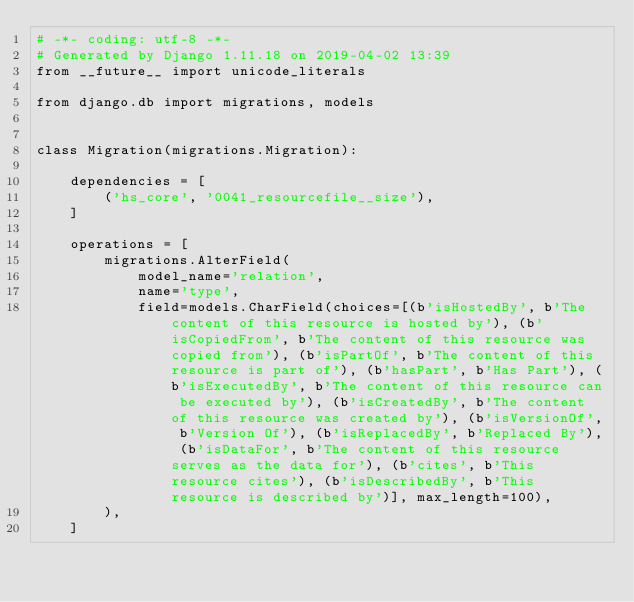<code> <loc_0><loc_0><loc_500><loc_500><_Python_># -*- coding: utf-8 -*-
# Generated by Django 1.11.18 on 2019-04-02 13:39
from __future__ import unicode_literals

from django.db import migrations, models


class Migration(migrations.Migration):

    dependencies = [
        ('hs_core', '0041_resourcefile__size'),
    ]

    operations = [
        migrations.AlterField(
            model_name='relation',
            name='type',
            field=models.CharField(choices=[(b'isHostedBy', b'The content of this resource is hosted by'), (b'isCopiedFrom', b'The content of this resource was copied from'), (b'isPartOf', b'The content of this resource is part of'), (b'hasPart', b'Has Part'), (b'isExecutedBy', b'The content of this resource can be executed by'), (b'isCreatedBy', b'The content of this resource was created by'), (b'isVersionOf', b'Version Of'), (b'isReplacedBy', b'Replaced By'), (b'isDataFor', b'The content of this resource serves as the data for'), (b'cites', b'This resource cites'), (b'isDescribedBy', b'This resource is described by')], max_length=100),
        ),
    ]
</code> 